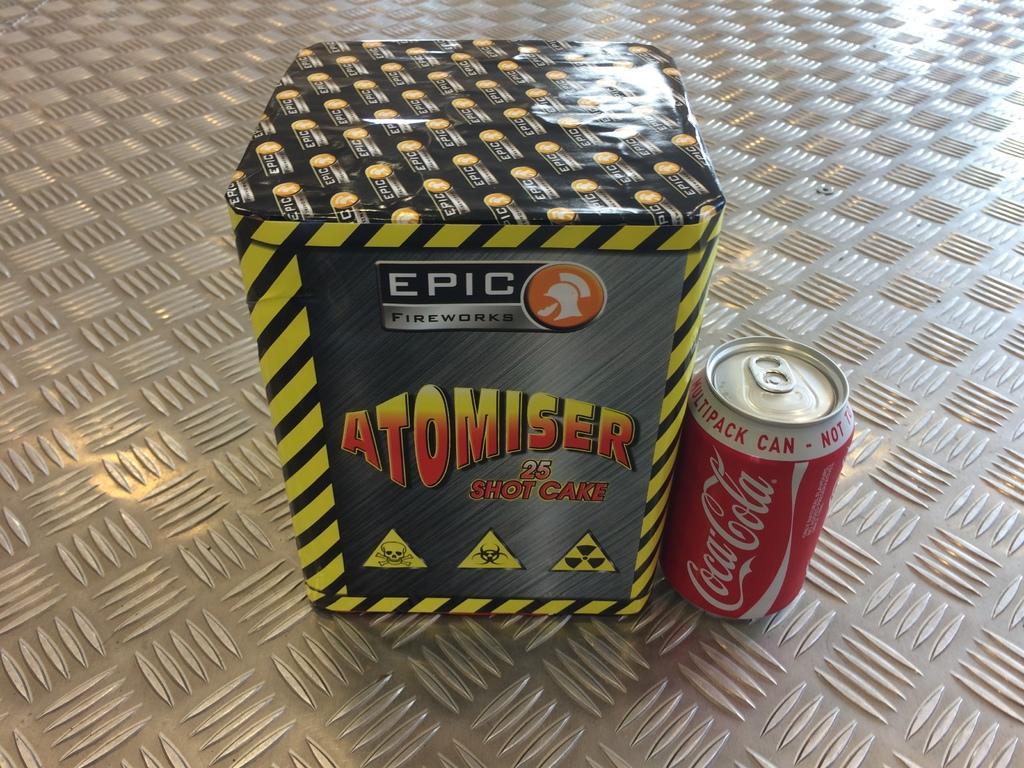Describe this image in one or two sentences. this picture there is a box and a soft drink tin in the center of the image. 